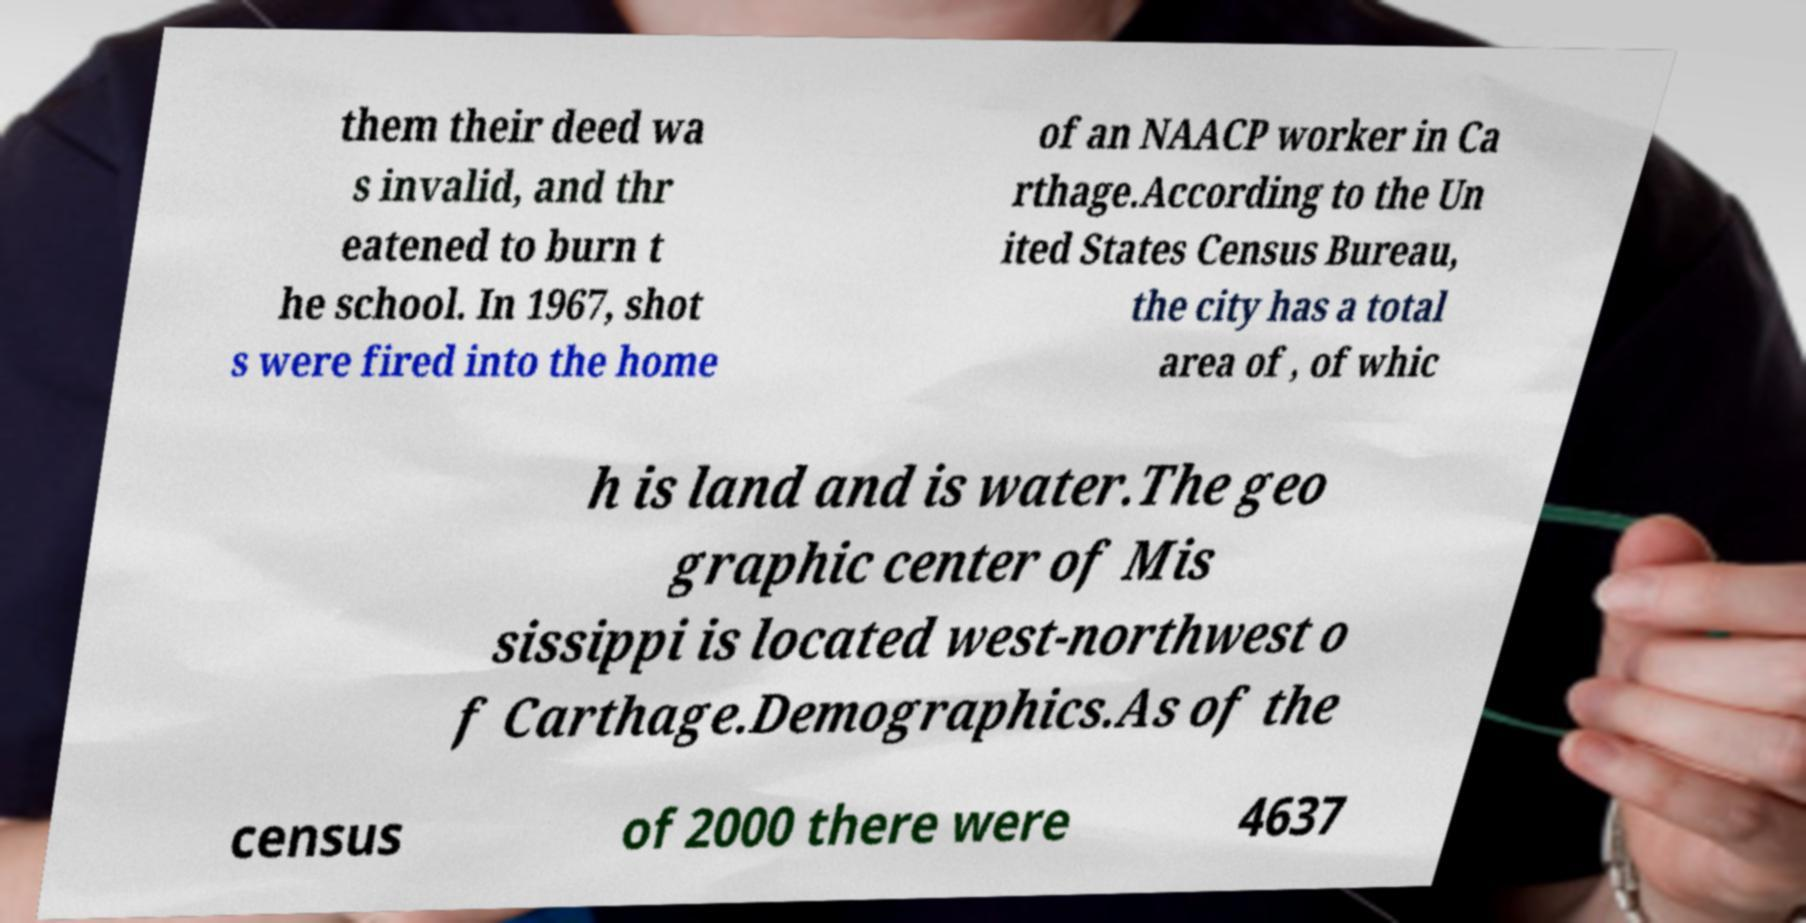There's text embedded in this image that I need extracted. Can you transcribe it verbatim? them their deed wa s invalid, and thr eatened to burn t he school. In 1967, shot s were fired into the home of an NAACP worker in Ca rthage.According to the Un ited States Census Bureau, the city has a total area of , of whic h is land and is water.The geo graphic center of Mis sissippi is located west-northwest o f Carthage.Demographics.As of the census of 2000 there were 4637 